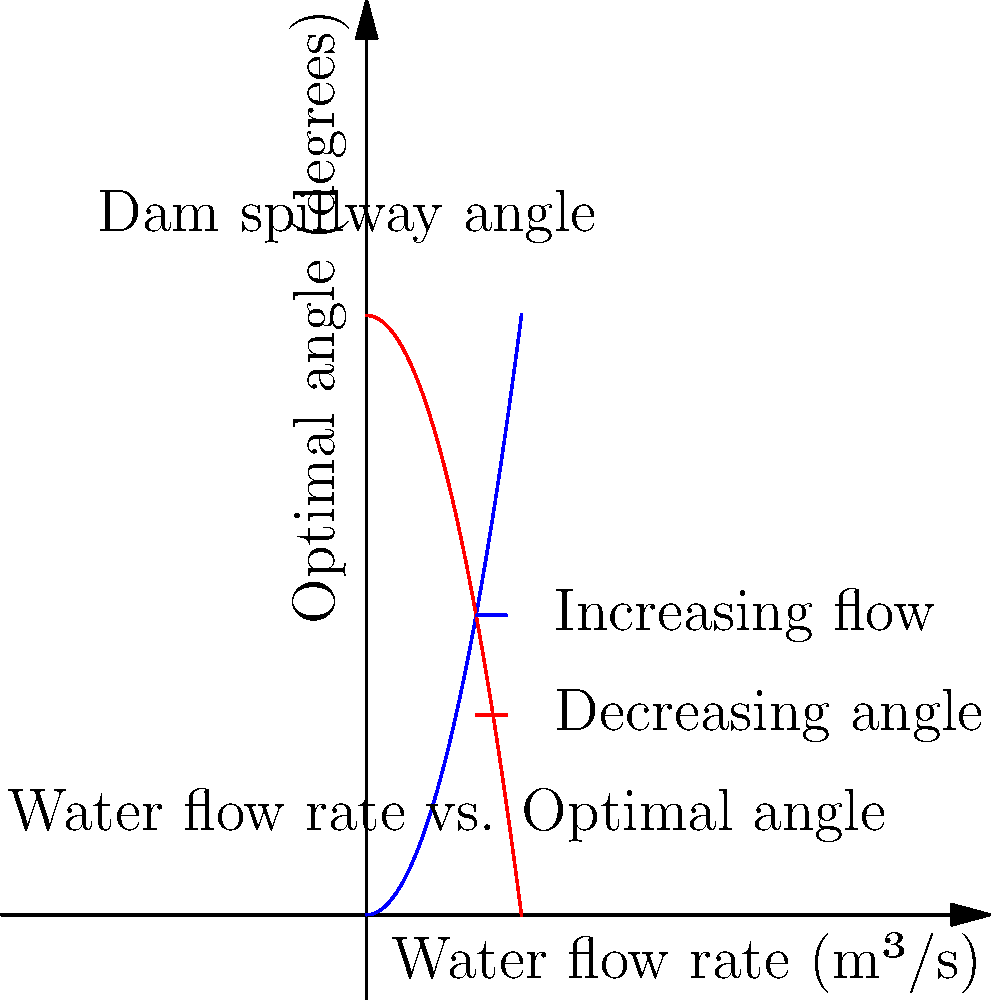G'day mate! Imagine you're designing a dam spillway for a new project in the Outback. The graph shows the relationship between water flow rate and the optimal angle for the spillway. If the expected maximum flow rate during a flood is 6 m³/s, what would be the recommended spillway angle to ensure efficient water discharge? Let's approach this step-by-step, keeping in mind the country music vibe of Georgia State Line:

1) First, we need to understand what the graph is showing us. The blue curve represents how the optimal angle increases with water flow rate, while the red curve shows how it decreases.

2) We're interested in the point where these two curves intersect for our given flow rate of 6 m³/s.

3) To find this point, we can use the equations of the curves:
   Blue curve: $y = 0.5x^2$
   Red curve: $y = 30 - 0.5x^2$

4) At the intersection point, these equations are equal:
   $0.5x^2 = 30 - 0.5x^2$

5) Solving for x = 6 (our flow rate):
   $0.5(6)^2 = 30 - 0.5(6)^2$
   $18 = 30 - 18$
   $18 = 12$

6) The y-value (angle) at this point is:
   $y = 0.5(6)^2 = 18$

7) Therefore, for a flow rate of 6 m³/s, the optimal spillway angle is 18 degrees.

This angle will ensure that the water flows smoothly over the spillway, just like a Georgia State Line melody flowing through the speakers at an Aussie country music festival!
Answer: 18 degrees 